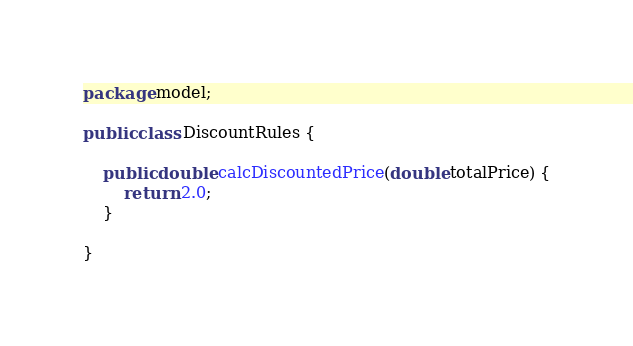<code> <loc_0><loc_0><loc_500><loc_500><_Java_>package model;

public class DiscountRules {
	
	public double calcDiscountedPrice(double totalPrice) {
		return 2.0;
	}
	
}
</code> 